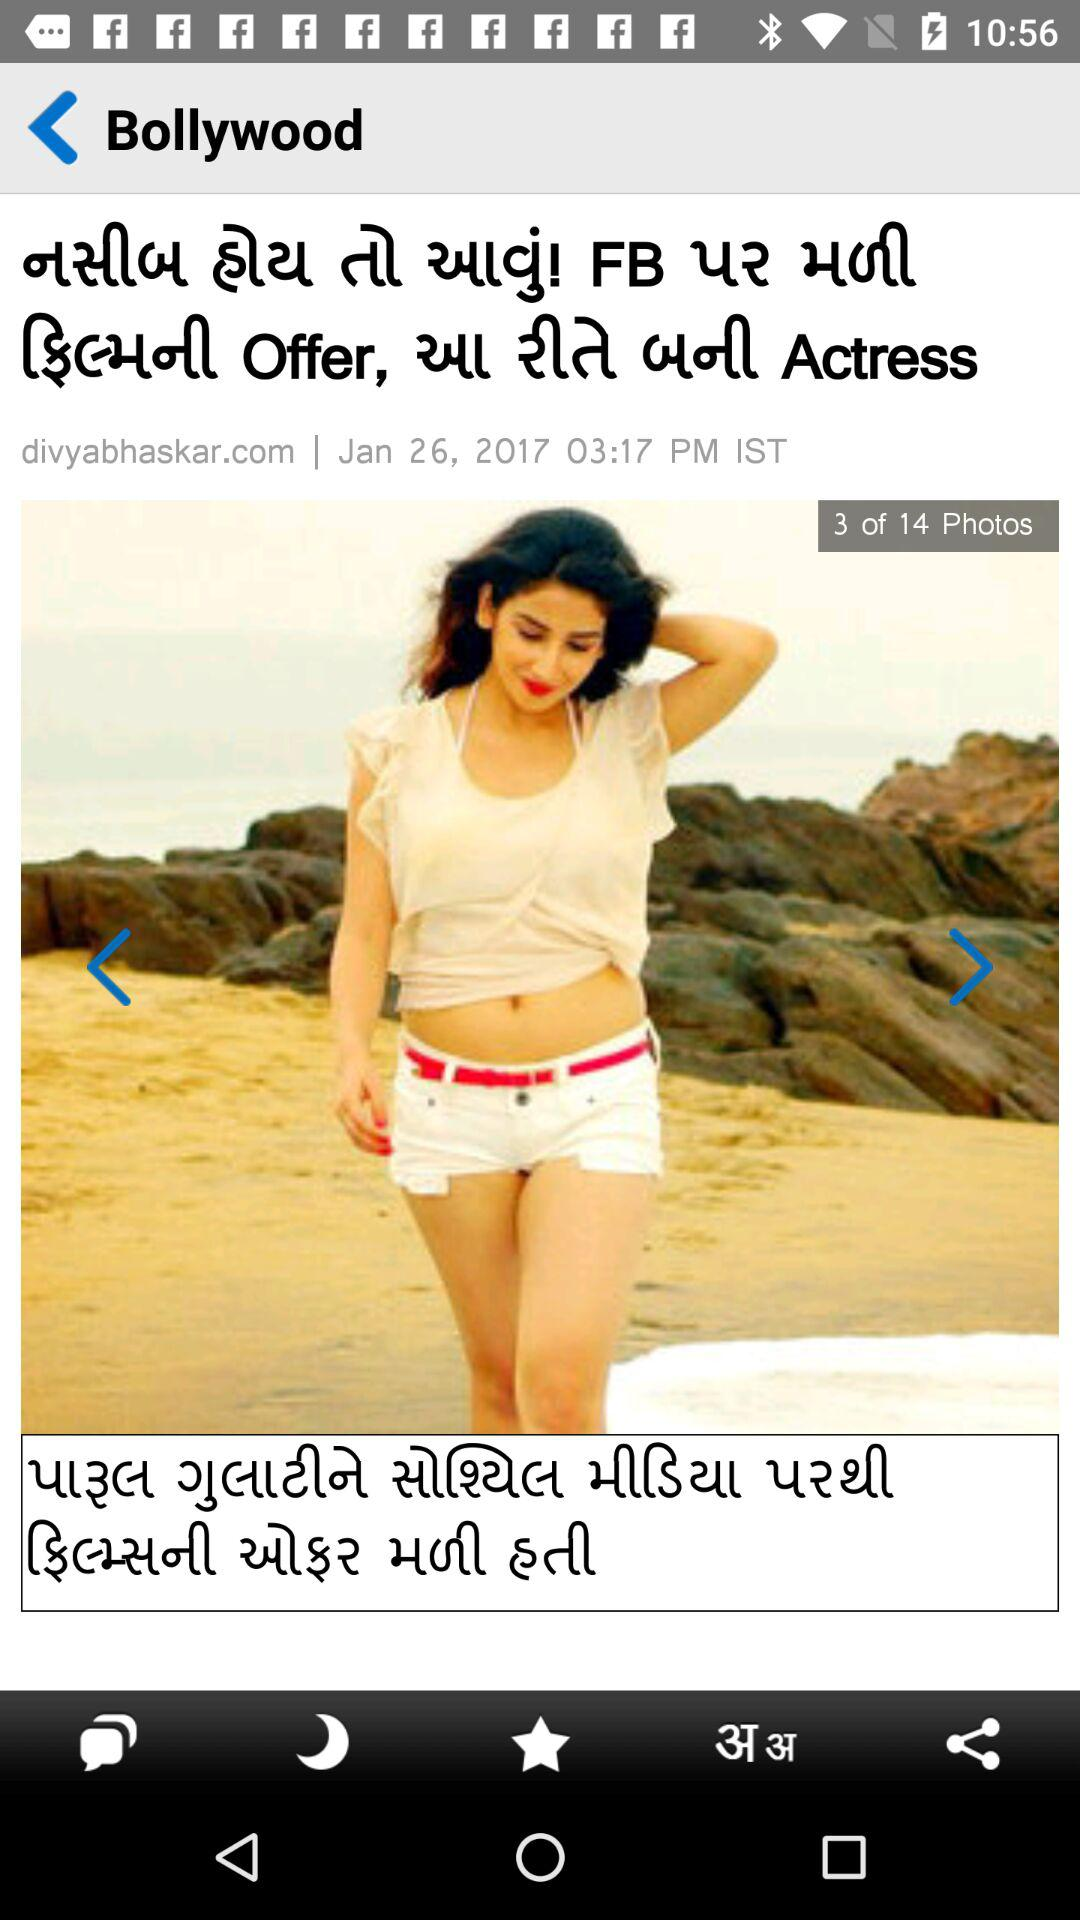How many photos are in the article?
Answer the question using a single word or phrase. 14 